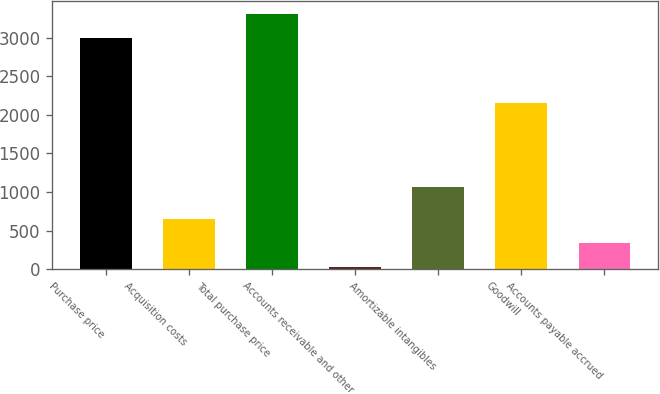<chart> <loc_0><loc_0><loc_500><loc_500><bar_chart><fcel>Purchase price<fcel>Acquisition costs<fcel>Total purchase price<fcel>Accounts receivable and other<fcel>Amortizable intangibles<fcel>Goodwill<fcel>Accounts payable accrued<nl><fcel>3000<fcel>649.4<fcel>3311.2<fcel>27<fcel>1060<fcel>2159<fcel>338.2<nl></chart> 